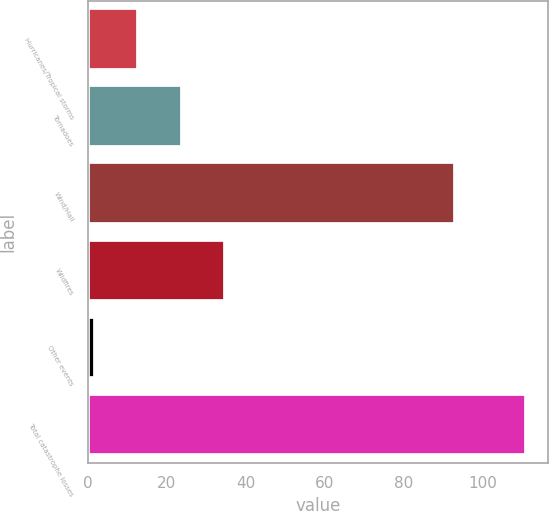Convert chart. <chart><loc_0><loc_0><loc_500><loc_500><bar_chart><fcel>Hurricanes/Tropical storms<fcel>Tornadoes<fcel>Wind/Hail<fcel>Wildfires<fcel>Other events<fcel>Total catastrophe losses<nl><fcel>12.9<fcel>23.8<fcel>93<fcel>34.7<fcel>2<fcel>111<nl></chart> 